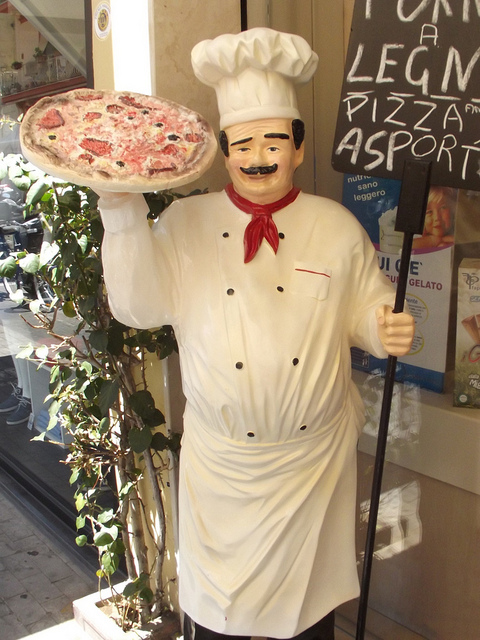Where would I likely find this type of statue? You're likely to find this type of statue outside pizzerias or Italian restaurants, typically in areas with heavy foot traffic to catch the eyes of people passing by and entice them to come in and enjoy a meal. Are there any characteristic features that make it stand out? Characteristic features of this statue that stand out include its life-sized proportions, the three-dimensional, tactile nature of the pizza, and the chef's inviting pose, with one hand outstretched as if offering the pizza to onlookers. 